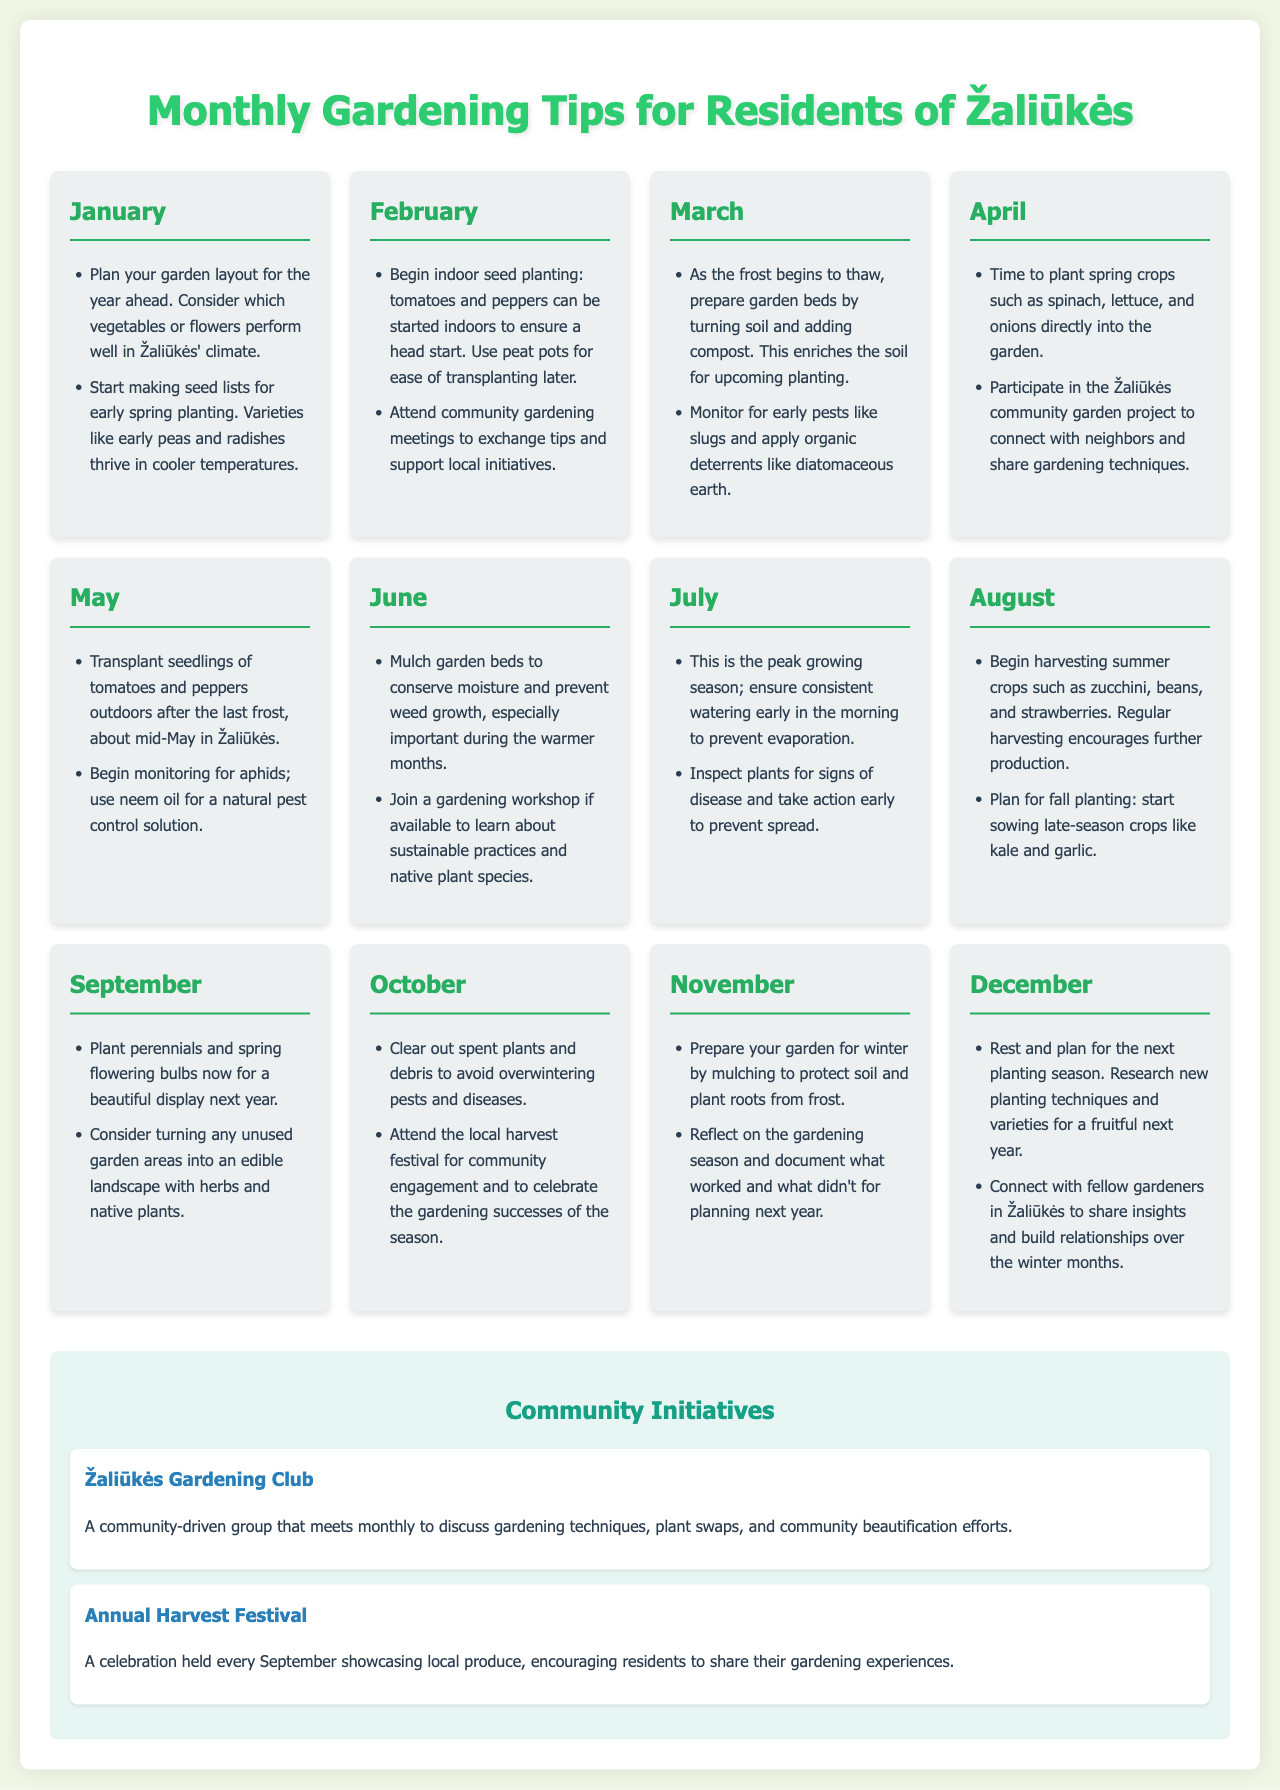What is the title of the document? The title of the document is found in the header section.
Answer: Monthly Gardening Tips for Residents of Žaliūkės What month advises on indoor seed planting? The document lists activities by month, indicating February as the month for indoor seed planting.
Answer: February Which pest control method is suggested in May? The pest control method suitable for May is noted within the month's activities.
Answer: Neem oil What types of crops should be planted in April? The document specifies which crops are suitable for planting in April.
Answer: Spinach, lettuce, and onions In which month is the Annual Harvest Festival held? The festival is mentioned in the community initiatives section explicitly stating its month.
Answer: September How should garden beds be prepared in March? The document explains the preparation methods for garden beds in March.
Answer: Turning soil and adding compost What is the main focus of the Žaliūkės Gardening Club? The focus of the gardening club is explained in the initiatives section.
Answer: Gardening techniques Which month involves reflecting on the gardening season? The reflective activity is specifically attributed to one month in the document.
Answer: November How often does the Žaliūkės Gardening Club meet? This frequency is mentioned in the initiatives section related to the gardening club.
Answer: Monthly 